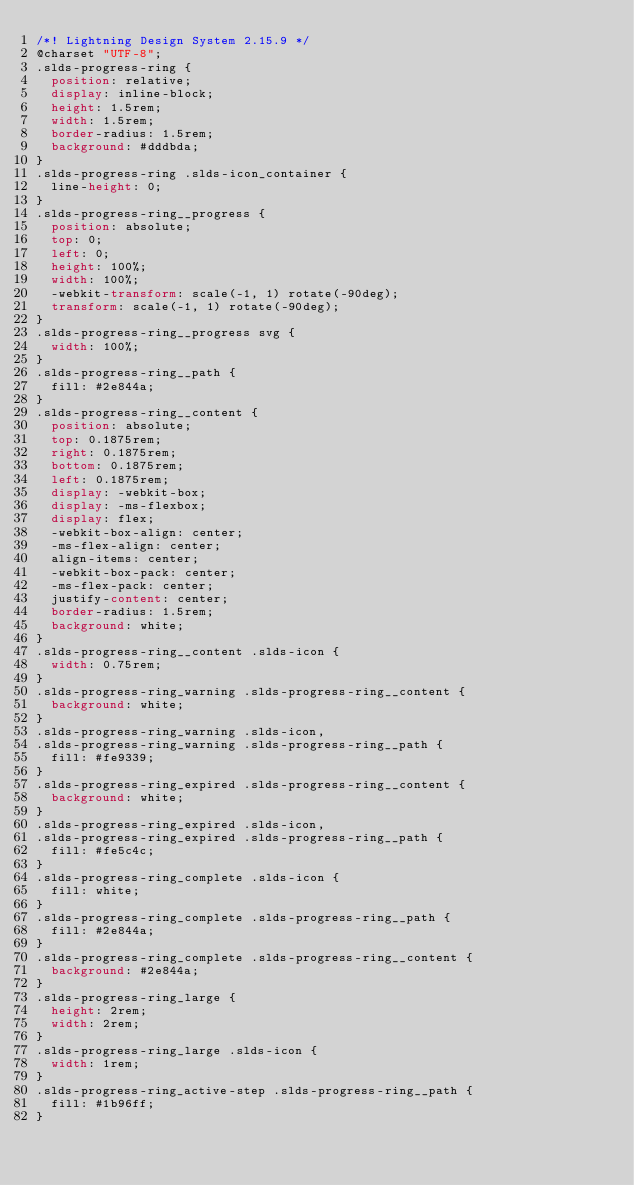<code> <loc_0><loc_0><loc_500><loc_500><_CSS_>/*! Lightning Design System 2.15.9 */
@charset "UTF-8";
.slds-progress-ring {
  position: relative;
  display: inline-block;
  height: 1.5rem;
  width: 1.5rem;
  border-radius: 1.5rem;
  background: #dddbda;
}
.slds-progress-ring .slds-icon_container {
  line-height: 0;
}
.slds-progress-ring__progress {
  position: absolute;
  top: 0;
  left: 0;
  height: 100%;
  width: 100%;
  -webkit-transform: scale(-1, 1) rotate(-90deg);
  transform: scale(-1, 1) rotate(-90deg);
}
.slds-progress-ring__progress svg {
  width: 100%;
}
.slds-progress-ring__path {
  fill: #2e844a;
}
.slds-progress-ring__content {
  position: absolute;
  top: 0.1875rem;
  right: 0.1875rem;
  bottom: 0.1875rem;
  left: 0.1875rem;
  display: -webkit-box;
  display: -ms-flexbox;
  display: flex;
  -webkit-box-align: center;
  -ms-flex-align: center;
  align-items: center;
  -webkit-box-pack: center;
  -ms-flex-pack: center;
  justify-content: center;
  border-radius: 1.5rem;
  background: white;
}
.slds-progress-ring__content .slds-icon {
  width: 0.75rem;
}
.slds-progress-ring_warning .slds-progress-ring__content {
  background: white;
}
.slds-progress-ring_warning .slds-icon,
.slds-progress-ring_warning .slds-progress-ring__path {
  fill: #fe9339;
}
.slds-progress-ring_expired .slds-progress-ring__content {
  background: white;
}
.slds-progress-ring_expired .slds-icon,
.slds-progress-ring_expired .slds-progress-ring__path {
  fill: #fe5c4c;
}
.slds-progress-ring_complete .slds-icon {
  fill: white;
}
.slds-progress-ring_complete .slds-progress-ring__path {
  fill: #2e844a;
}
.slds-progress-ring_complete .slds-progress-ring__content {
  background: #2e844a;
}
.slds-progress-ring_large {
  height: 2rem;
  width: 2rem;
}
.slds-progress-ring_large .slds-icon {
  width: 1rem;
}
.slds-progress-ring_active-step .slds-progress-ring__path {
  fill: #1b96ff;
}
</code> 